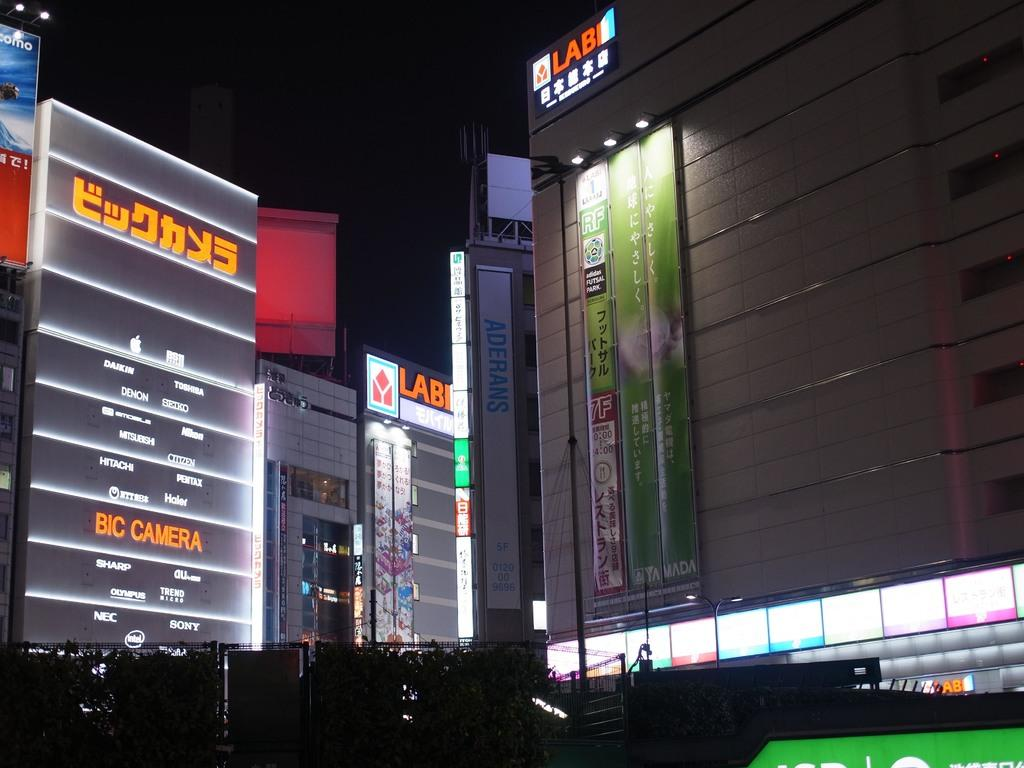Provide a one-sentence caption for the provided image. Several major electronic companies are advertised on the neon signs such as Sony, Sharp and Toshiba. 